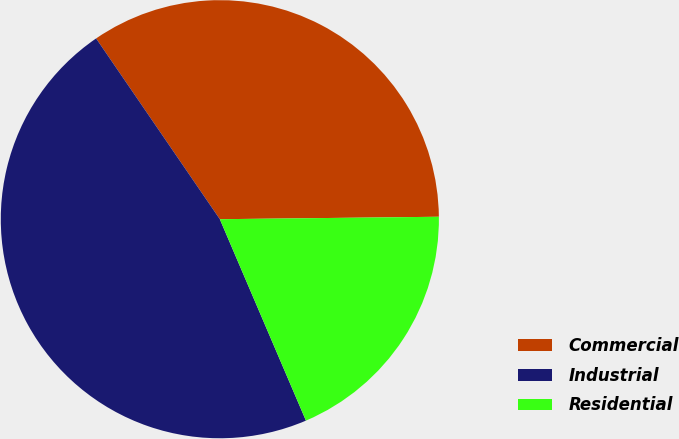Convert chart. <chart><loc_0><loc_0><loc_500><loc_500><pie_chart><fcel>Commercial<fcel>Industrial<fcel>Residential<nl><fcel>34.38%<fcel>46.88%<fcel>18.75%<nl></chart> 